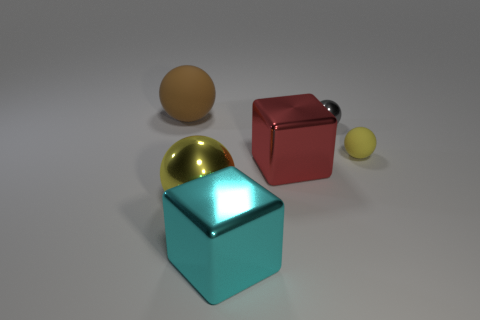Subtract all big yellow metal spheres. How many spheres are left? 3 Subtract all gray spheres. How many spheres are left? 3 Add 1 spheres. How many objects exist? 7 Subtract 1 spheres. How many spheres are left? 3 Subtract all blue spheres. Subtract all gray cylinders. How many spheres are left? 4 Add 4 cyan metal objects. How many cyan metal objects are left? 5 Add 3 brown matte things. How many brown matte things exist? 4 Subtract 1 brown spheres. How many objects are left? 5 Subtract all blocks. How many objects are left? 4 Subtract all green metallic spheres. Subtract all big metallic objects. How many objects are left? 3 